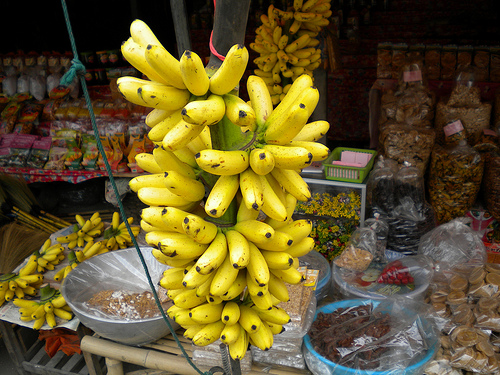Describe the atmosphere of the place where this photo was taken. The photograph captures the essence of a vibrant and colorful open-air market, filled with the buzz of vendors and shoppers engaged in the lively ritual of trading fresh local produce and goods. 